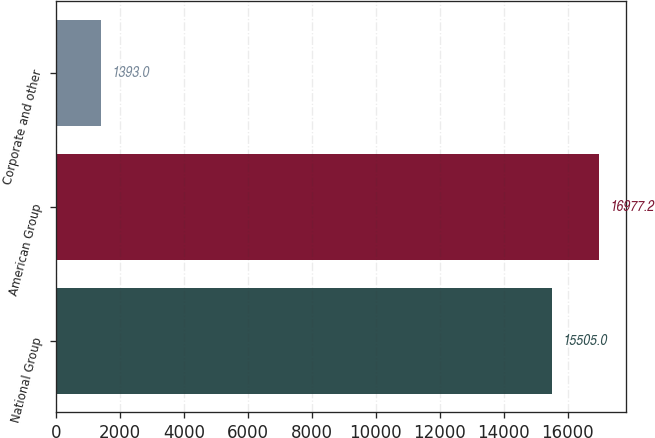<chart> <loc_0><loc_0><loc_500><loc_500><bar_chart><fcel>National Group<fcel>American Group<fcel>Corporate and other<nl><fcel>15505<fcel>16977.2<fcel>1393<nl></chart> 